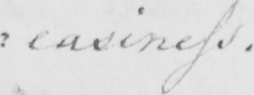Please transcribe the handwritten text in this image. : easiness . 